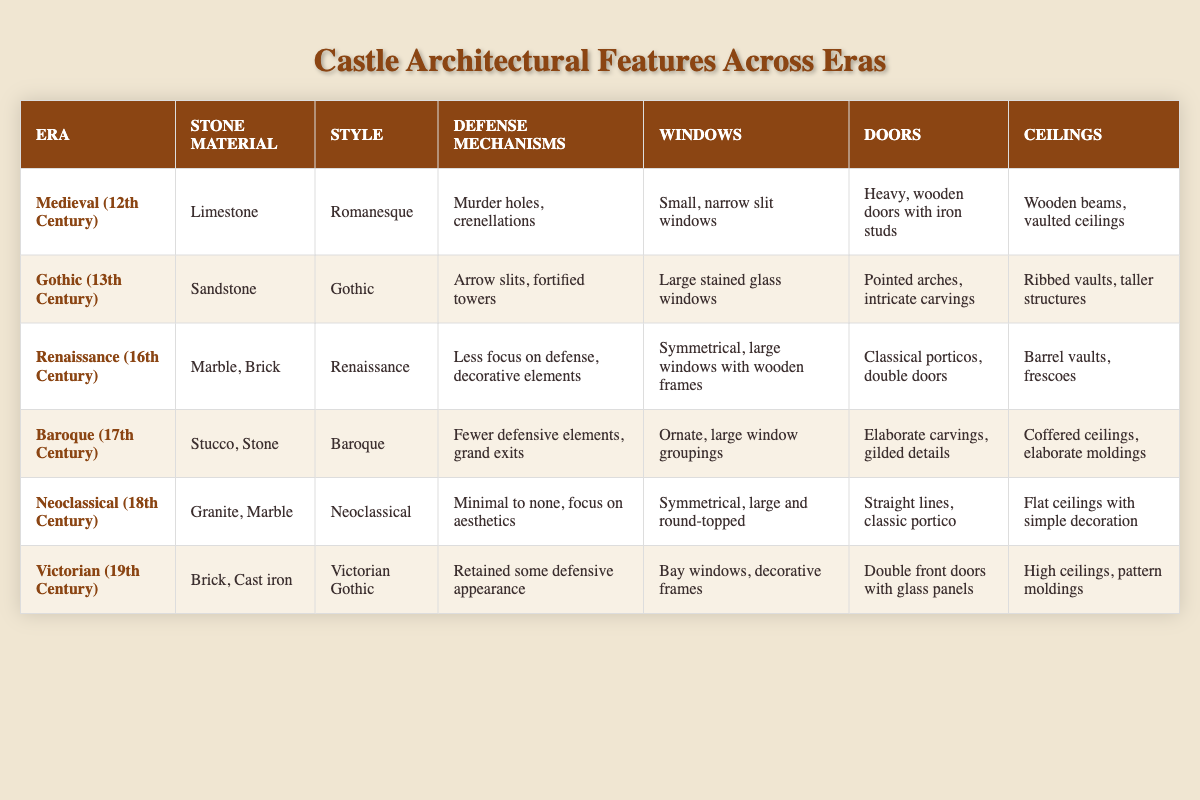What stone material was used in the Gothic era? Referring to the table, under the "Gothic (13th Century)" entry, the stone material is listed as "Sandstone."
Answer: Sandstone Which era featured large stained glass windows? The table indicates that large stained glass windows are a feature of the "Gothic (13th Century)" era.
Answer: Gothic (13th Century) What is the main defense mechanism used in the Medieval era? The table shows that the Medieval era (12th Century) utilized "Murder holes, crenellations" as defense mechanisms.
Answer: Murder holes, crenellations Did the Renaissance era focus on defense? According to the table, the Renaissance era had "Less focus on defense, decorative elements," indicating a shift away from defensive structures.
Answer: No How many different styles of architecture are listed in the table? The table lists six different styles corresponding to the six eras: Romanesque, Gothic, Renaissance, Baroque, Neoclassical, and Victorian Gothic. The total count is 6.
Answer: 6 Which era had ceilings described as "high ceilings, pattern moldings"? The feature "high ceilings, pattern moldings" is associated with the Victorian (19th Century) era in the table.
Answer: Victorian (19th Century) What is the primary material used in the Renaissance era? The table specifies that the Renaissance era primarily used "Marble, Brick" as materials.
Answer: Marble, Brick Identify the era with the least emphasis on defensive features and its defense mechanism description. The table indicates that the Neoclassical (18th Century) era had "Minimal to none, focus on aesthetics" as its defense mechanisms, signifying the least emphasis on defense.
Answer: Neoclassical (18th Century), Minimal to none How does the number of stone materials change from the Medieval era to the Neoclassical era? The Medieval era uses one stone material (Limestone), while the Neoclassical era uses two (Granite, Marble). The difference is one additional material.
Answer: Increases by 1 What similarities exist between the window designs of the Renaissance and Neoclassical eras? Both the Renaissance and Neoclassical eras feature "Symmetrical" window designs. The Renaissance has "large windows with wooden frames," while the Neoclassical has "large and round-topped" windows, indicating a focus on symmetry.
Answer: Symmetrical design Which architectural style is linked to the most elaborate door features? The table notes that the Baroque (17th Century) era has "Elaborate carvings, gilded details" as descriptions for doors, indicating it is linked to the most elaborate features.
Answer: Baroque (17th Century) 